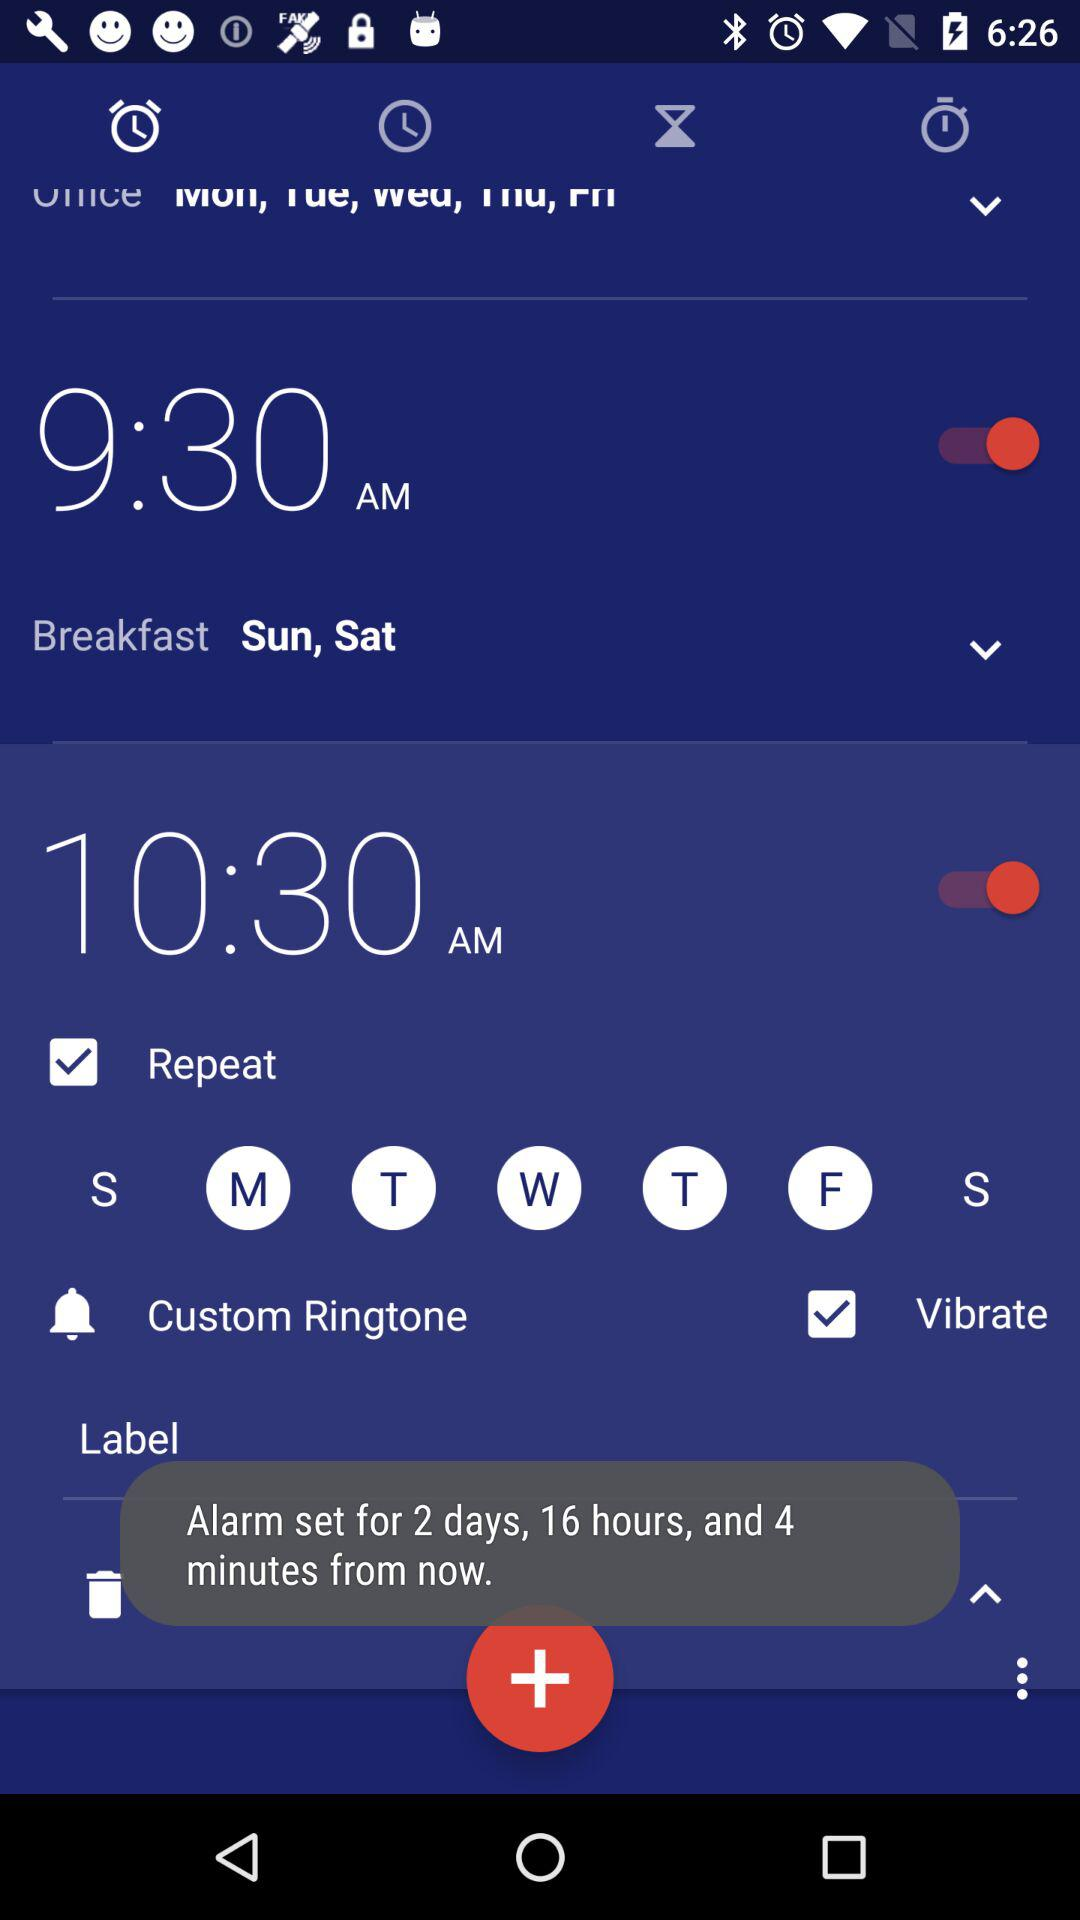For how many days from now is the alarm set? Alram is set for 2 days, 16 hours and 4 minutes. 